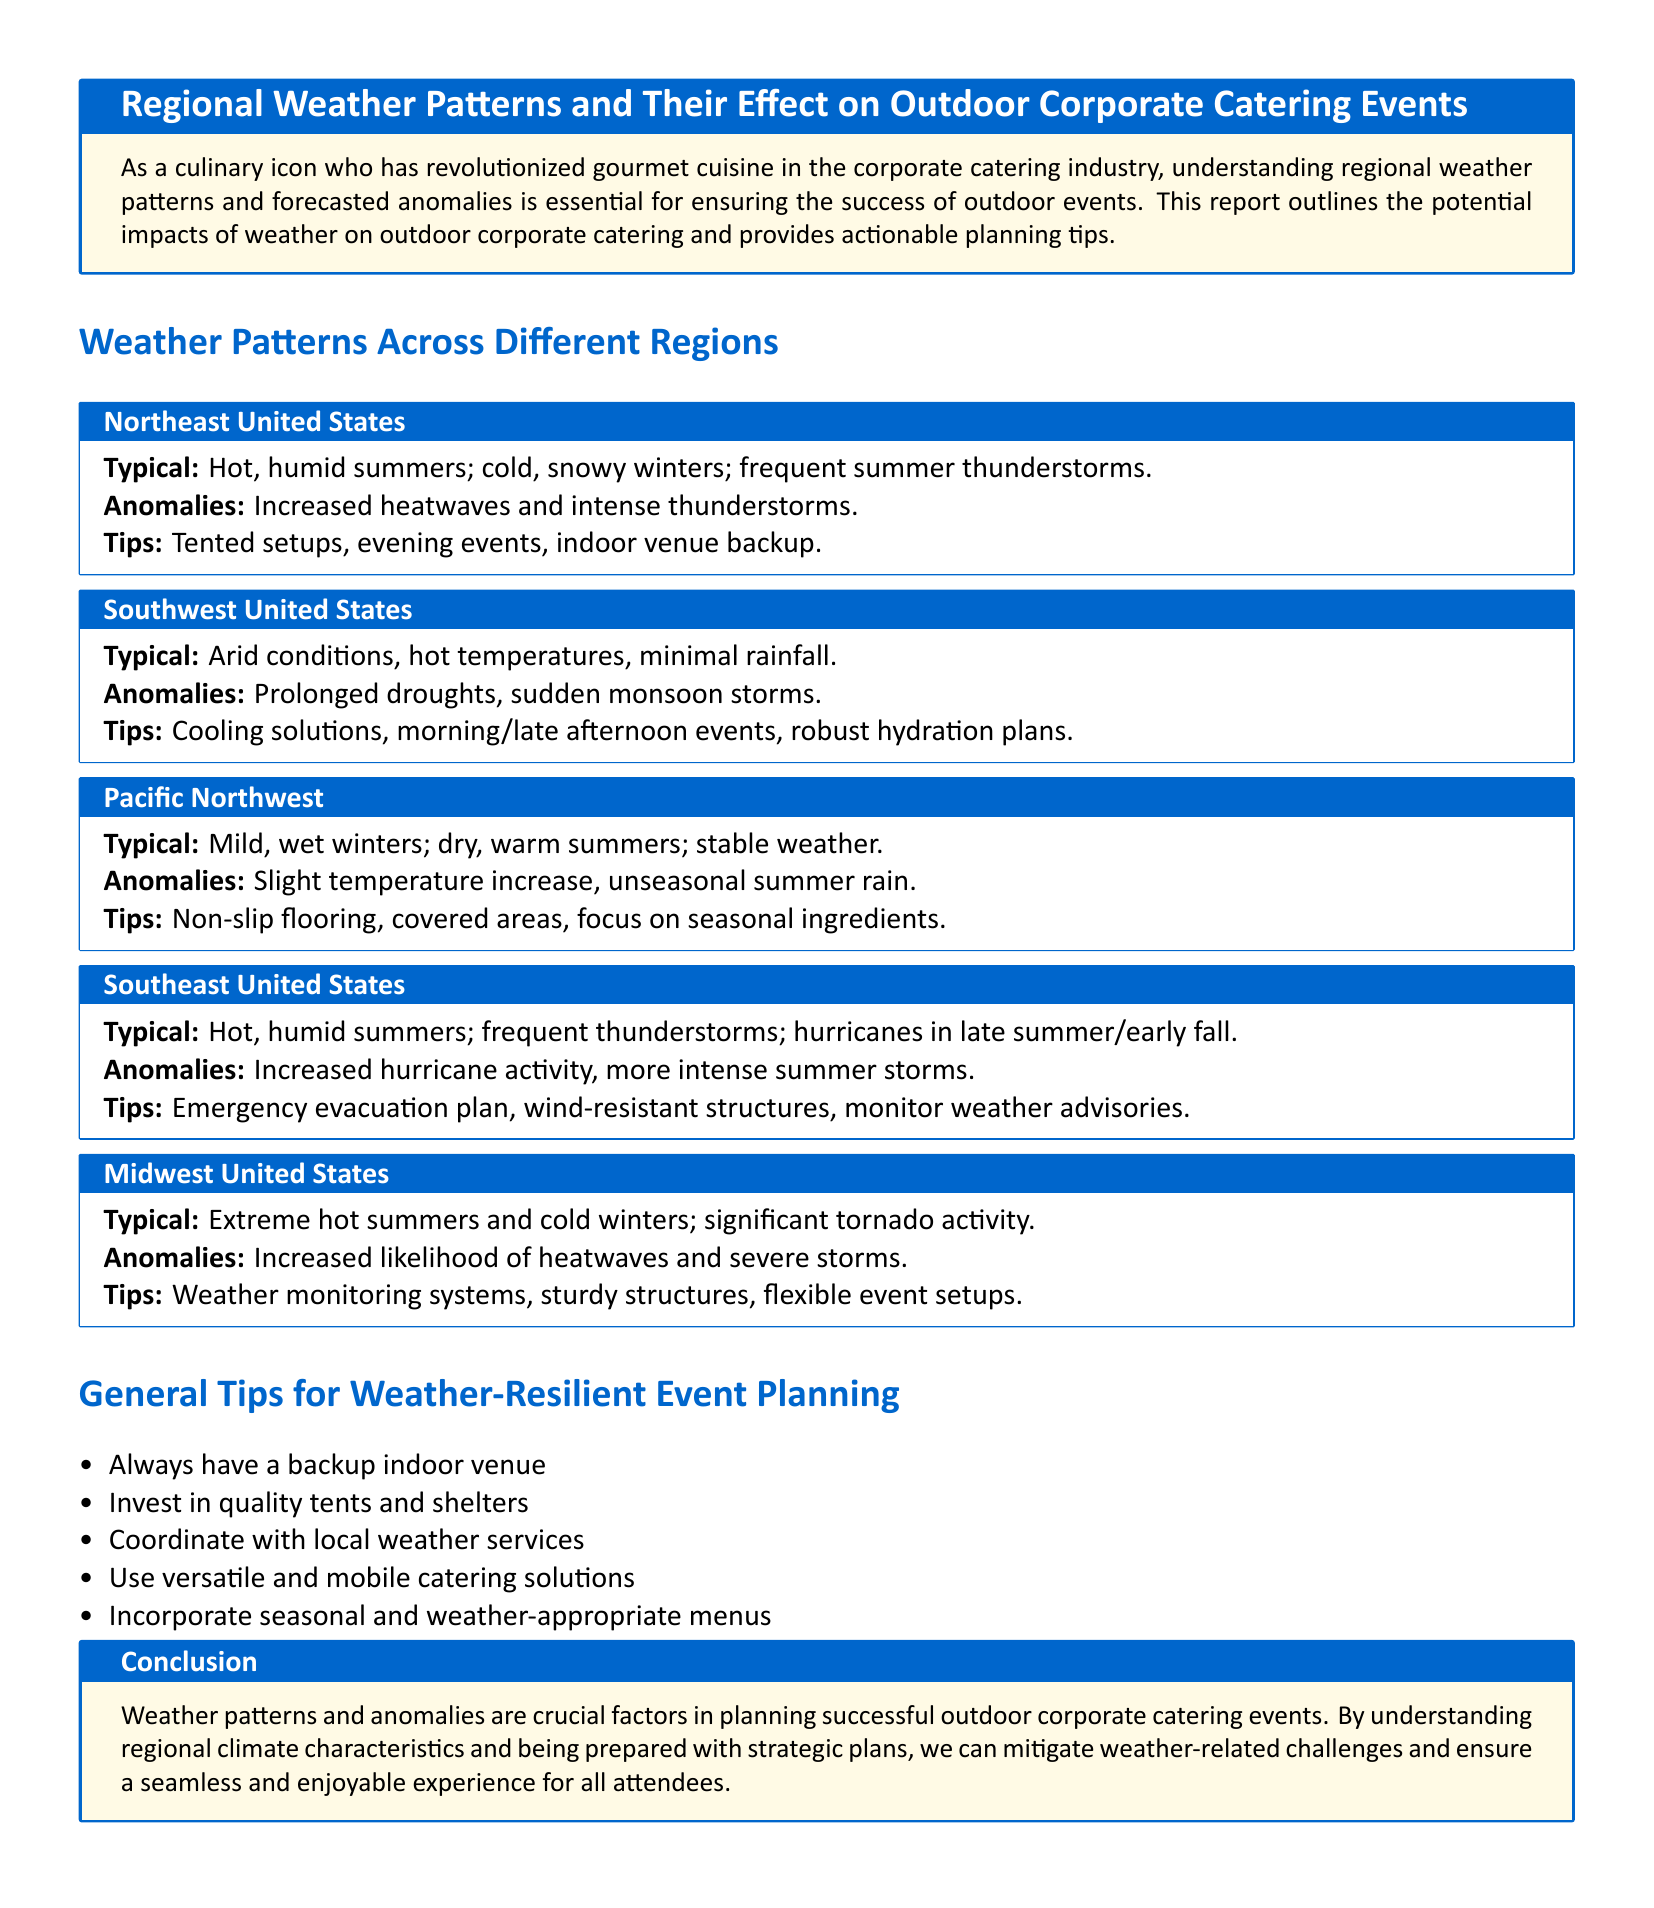What weather pattern is typical for the Northeast United States? The typical weather pattern for the Northeast includes hot, humid summers and cold, snowy winters.
Answer: Hot, humid summers; cold, snowy winters What is one anomaly expected in the Midwest United States? The document states that one anomaly for the Midwest is an increased likelihood of heatwaves and severe storms.
Answer: Increased likelihood of heatwaves What type of structures should be considered for events in the Southeast United States? The report suggests using wind-resistant structures for events in the Southeast due to frequent thunderstorms and hurricanes.
Answer: Wind-resistant structures Which region is characterized by arid conditions? The Southwest United States is characterized by arid conditions and hot temperatures.
Answer: Southwest United States What is a recommended tip for event planning in the Pacific Northwest? The document recommends using non-slip flooring for outdoor events in the Pacific Northwest due to the potential for wet weather.
Answer: Non-slip flooring What is a general tip mentioned for weather-resilient event planning? The document lists always having a backup indoor venue as a general tip for planning.
Answer: Backup indoor venue How does increased hurricane activity impact event planning in the Southeast United States? Increased hurricane activity requires an emergency evacuation plan as stated in the document.
Answer: Emergency evacuation plan What should event planners coordinate with for outdoor events? The document emphasizes coordinating with local weather services for successful outdoor events.
Answer: Local weather services Which season is mentioned for potential unseasonal rain in the Pacific Northwest? The report indicates unseasonal summer rain as a potential anomaly in the Pacific Northwest.
Answer: Summer 